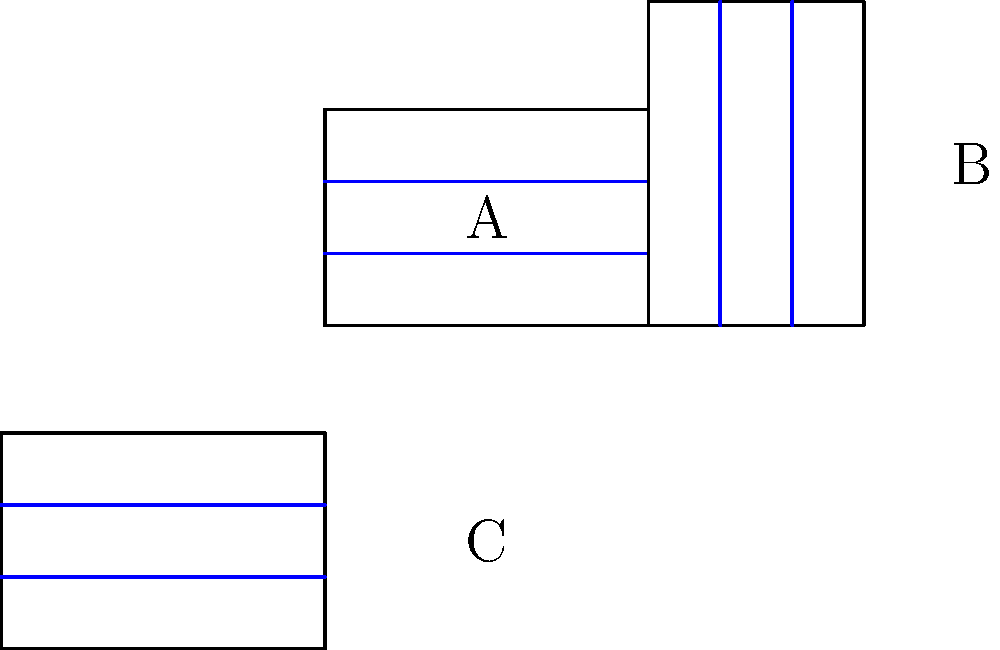Consider the three flag designs A, B, and C shown above. Flag B is obtained from flag A through a rotation, while flag C is obtained from flag A through a reflection. Which of the following group theory statements is correct regarding these transformations?

a) The rotation that transforms A to B, followed by the reflection that transforms A to C, results in flag A.
b) The reflection that transforms A to C, followed by the rotation that transforms A to B, results in flag A.
c) The rotation that transforms A to B and the reflection that transforms A to C commute.
d) The group generated by these two transformations is isomorphic to the cyclic group of order 4. Let's analyze this step-by-step:

1) First, let's identify the transformations:
   - R: 90° clockwise rotation (A to B)
   - F: Reflection across the vertical axis (A to C)

2) Now, let's consider the composition of these transformations:

   a) R followed by F:
      - R rotates A 90° clockwise
      - F then reflects this rotated flag across the vertical axis
      The result is not A, so option (a) is incorrect.

   b) F followed by R:
      - F reflects A across the vertical axis
      - R then rotates this reflected flag 90° clockwise
      The result is not A, so option (b) is incorrect.

3) To check if R and F commute, we need to verify if FR = RF:
   - FR results in a 90° counterclockwise rotation
   - RF results in a 90° clockwise rotation followed by a reflection across the horizontal axis
   These are not the same, so R and F do not commute. Option (c) is incorrect.

4) The group generated by R and F is actually the dihedral group D4, which has 8 elements:
   {I, R, R², R³, F, FR, FR², FR³}
   This group is not isomorphic to the cyclic group of order 4. So option (d) is also incorrect.

5) Since all given options are incorrect, the correct answer is that none of the statements are true.
Answer: None of the statements are correct. 